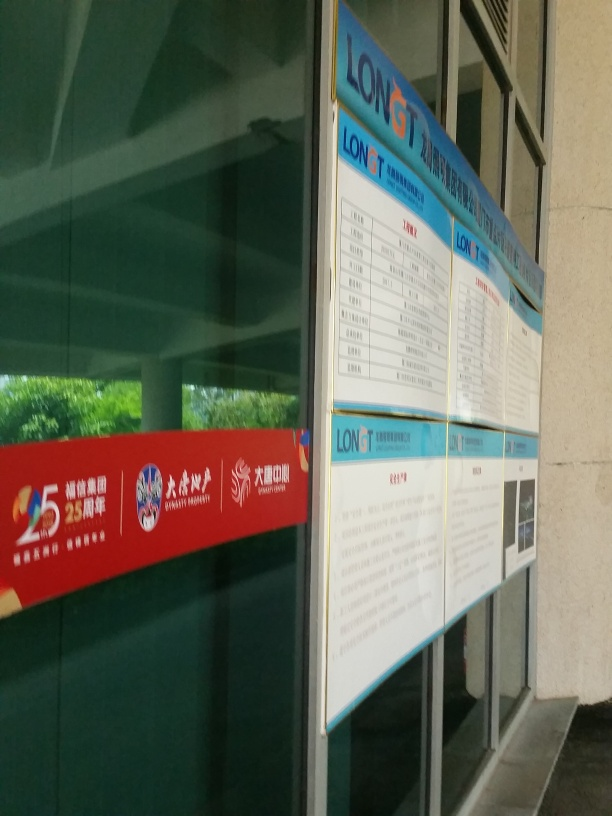Does the image suggest a location where this board could be found? The style of the board and the characters visible on the banners suggest that it is likely located in a Chinese-speaking region. The setting appears to be a public space, such as a train station or a government building. Is there anything that indicates a particular time of day or year? There is no direct indication of the time of day or year in the image. However, the natural light and the shadows suggest it could be daylight, although the exact time cannot be determined. The banners do not provide seasonal information either. 